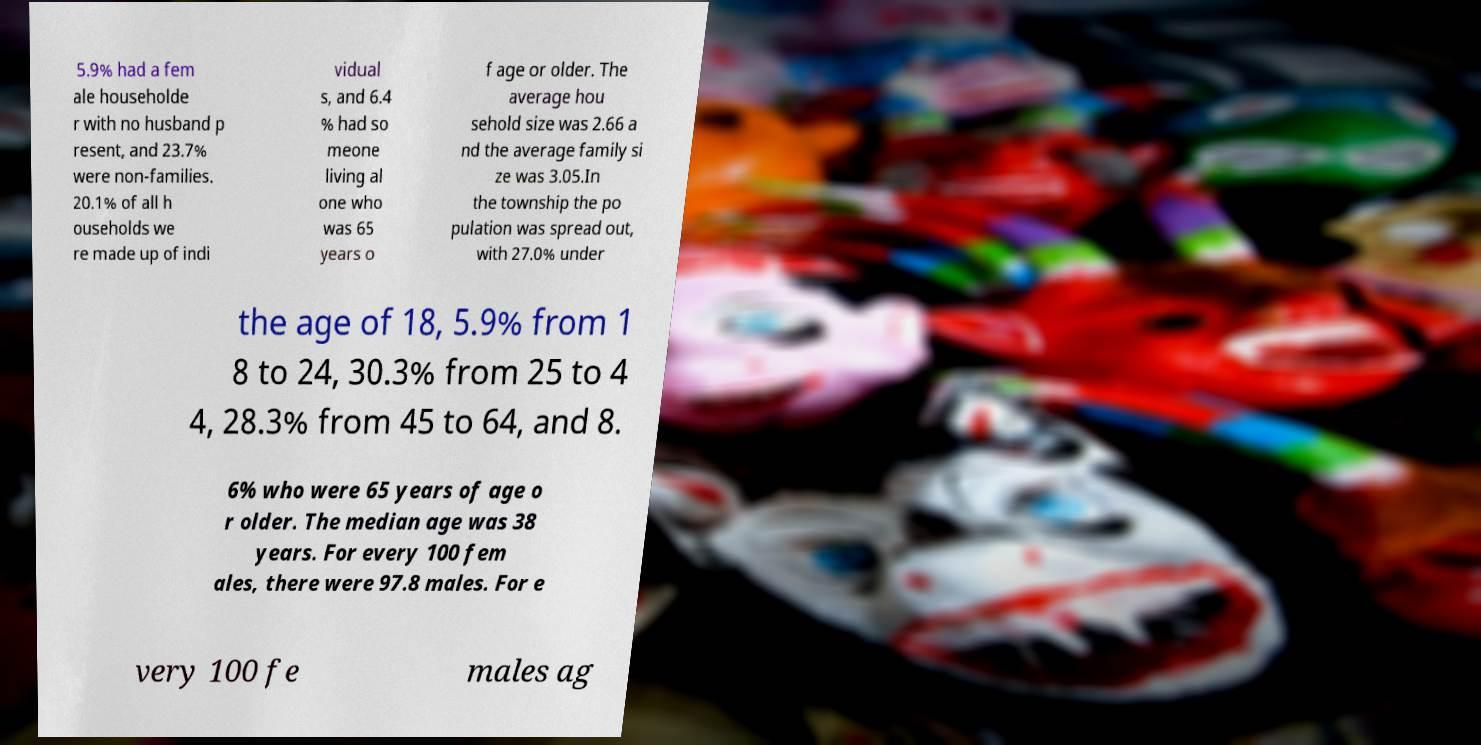For documentation purposes, I need the text within this image transcribed. Could you provide that? 5.9% had a fem ale householde r with no husband p resent, and 23.7% were non-families. 20.1% of all h ouseholds we re made up of indi vidual s, and 6.4 % had so meone living al one who was 65 years o f age or older. The average hou sehold size was 2.66 a nd the average family si ze was 3.05.In the township the po pulation was spread out, with 27.0% under the age of 18, 5.9% from 1 8 to 24, 30.3% from 25 to 4 4, 28.3% from 45 to 64, and 8. 6% who were 65 years of age o r older. The median age was 38 years. For every 100 fem ales, there were 97.8 males. For e very 100 fe males ag 